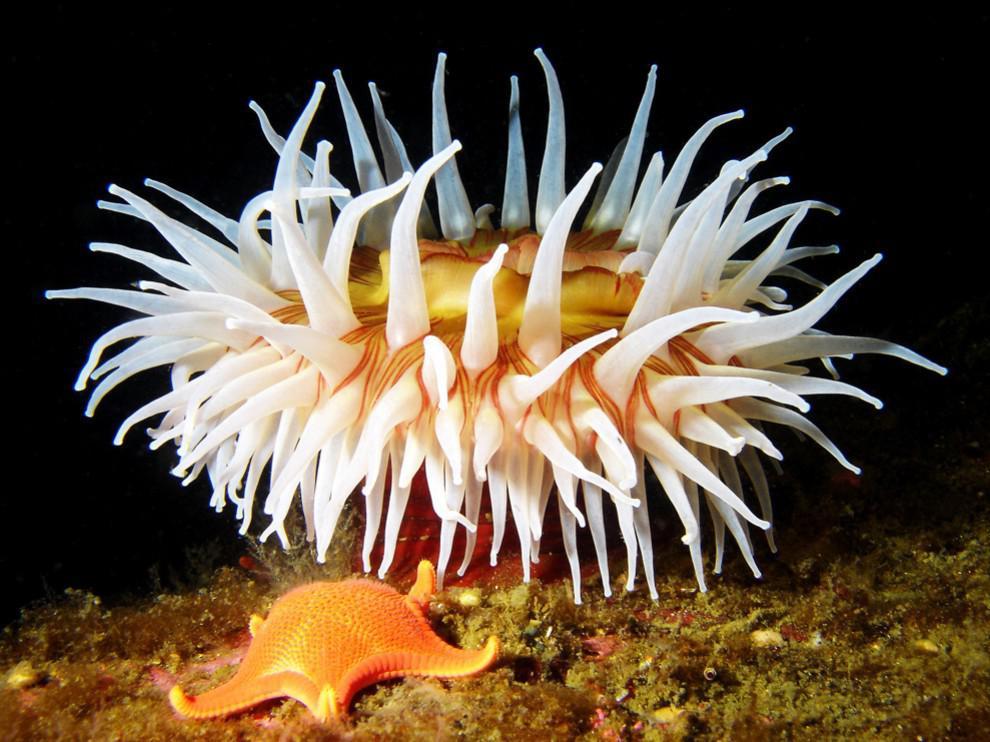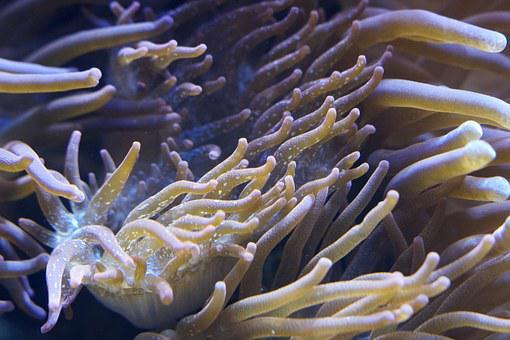The first image is the image on the left, the second image is the image on the right. Given the left and right images, does the statement "The left image contains an animal that is not an anemone." hold true? Answer yes or no. Yes. The first image is the image on the left, the second image is the image on the right. For the images shown, is this caption "At least one anemone image looks like spaghetti noodles rather than a flower shape." true? Answer yes or no. Yes. 